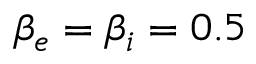Convert formula to latex. <formula><loc_0><loc_0><loc_500><loc_500>\beta _ { e } = \beta _ { i } = 0 . 5</formula> 